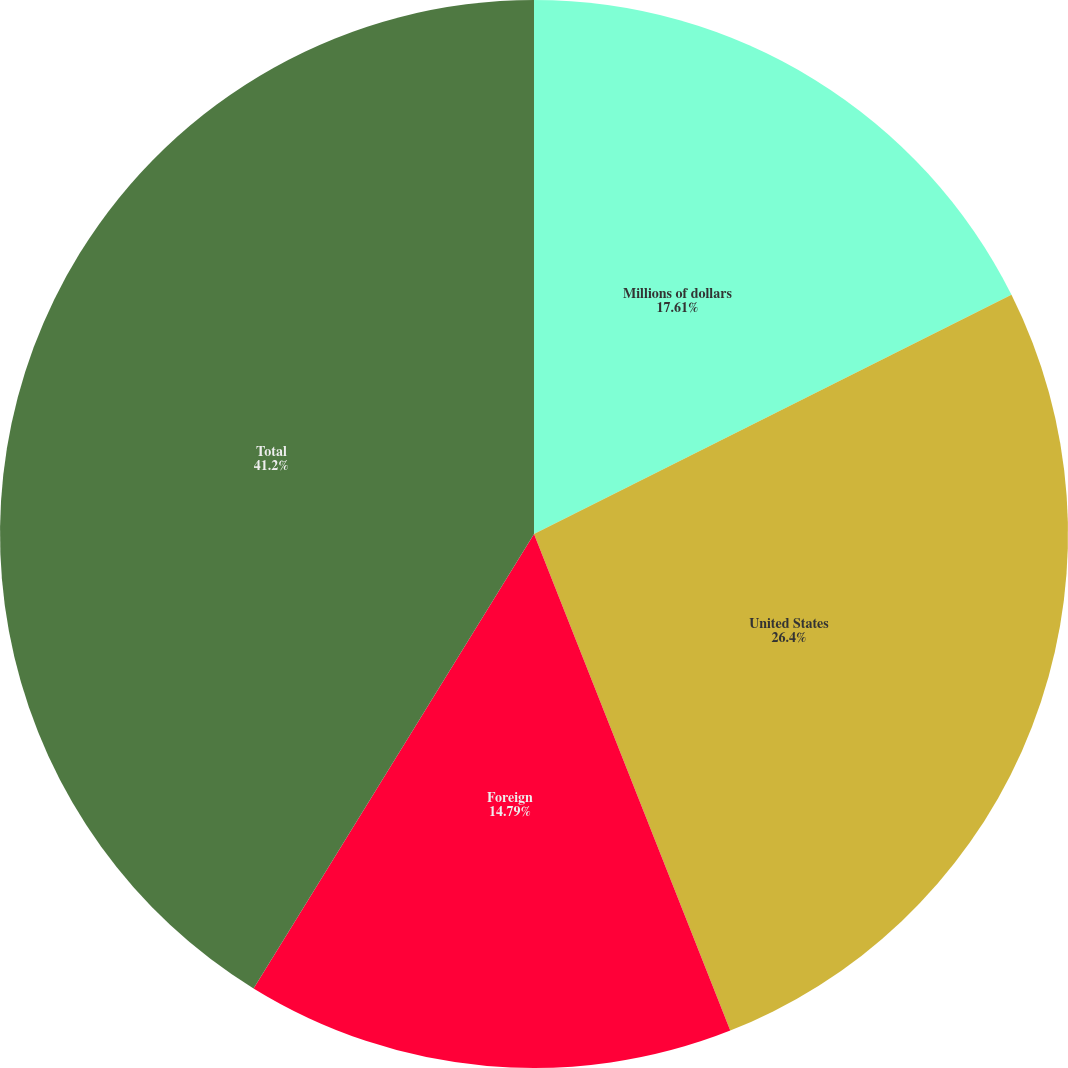<chart> <loc_0><loc_0><loc_500><loc_500><pie_chart><fcel>Millions of dollars<fcel>United States<fcel>Foreign<fcel>Total<nl><fcel>17.61%<fcel>26.4%<fcel>14.79%<fcel>41.2%<nl></chart> 